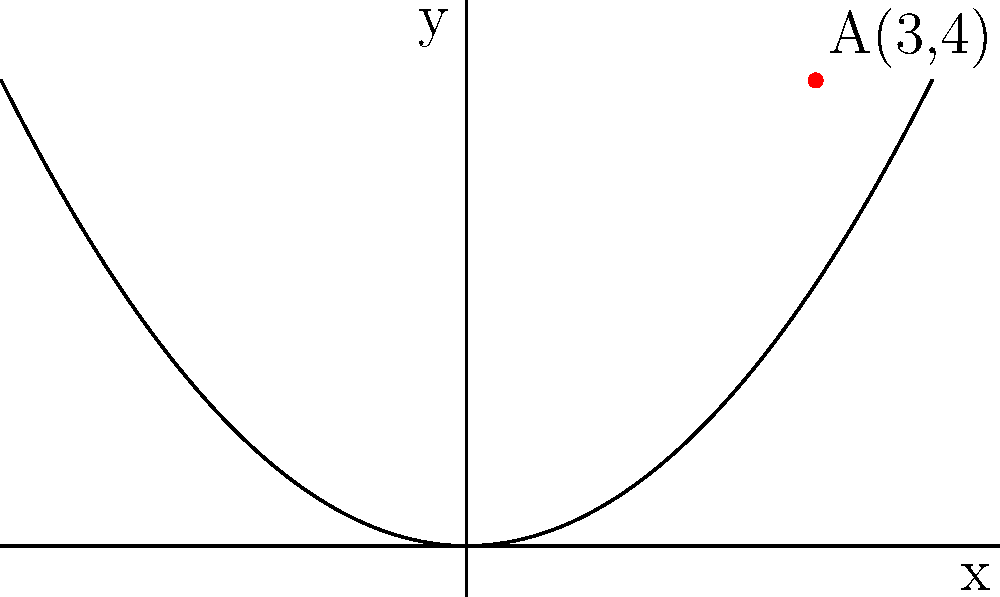Consider the parabola $y = \frac{x^2}{4}$ and the point $A(3,4)$. Find the shortest distance from point A to the parabola. How might this mathematical certainty challenge our emotional understanding of proximity and connection? Let's approach this step-by-step, while considering the emotional implications of each mathematical action:

1) The general point on the parabola is $(x, \frac{x^2}{4})$.

2) The distance $d$ between $A(3,4)$ and a point $(x, \frac{x^2}{4})$ on the parabola is given by:

   $$d = \sqrt{(x-3)^2 + (\frac{x^2}{4}-4)^2}$$

3) To find the minimum distance, we need to minimize this function. We can do this by differentiating $d^2$ with respect to $x$ and setting it to zero:

   $$\frac{d}{dx}(d^2) = \frac{d}{dx}[(x-3)^2 + (\frac{x^2}{4}-4)^2] = 0$$

4) Expanding this:

   $$2(x-3) + 2(\frac{x^2}{4}-4)(\frac{x}{2}) = 0$$

5) Simplifying:

   $$2x - 6 + \frac{x^3}{4} - 2x = 0$$
   $$\frac{x^3}{4} - 6 = 0$$
   $$x^3 = 24$$
   $$x = 2\sqrt[3]{3}$$

6) The $y$-coordinate of the closest point on the parabola is:

   $$y = \frac{(2\sqrt[3]{3})^2}{4} = \frac{4\sqrt[3]{9}}{4} = \sqrt[3]{9}$$

7) Therefore, the closest point on the parabola is $(2\sqrt[3]{3}, \sqrt[3]{9})$.

8) The shortest distance is:

   $$d = \sqrt{(2\sqrt[3]{3}-3)^2 + (\sqrt[3]{9}-4)^2}$$

This mathematical journey reveals that even in the realm of cold, hard numbers, we find unexpected connections and proximities. The parabola, infinitely extending yet never touching its axis, mirrors our own quest for closeness - always approaching, never quite reaching perfect union.
Answer: $\sqrt{(2\sqrt[3]{3}-3)^2 + (\sqrt[3]{9}-4)^2}$ 